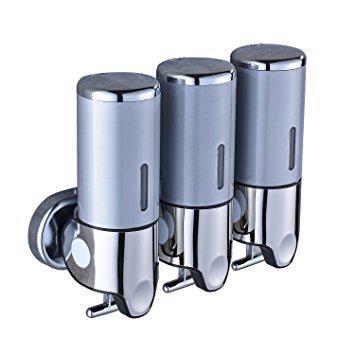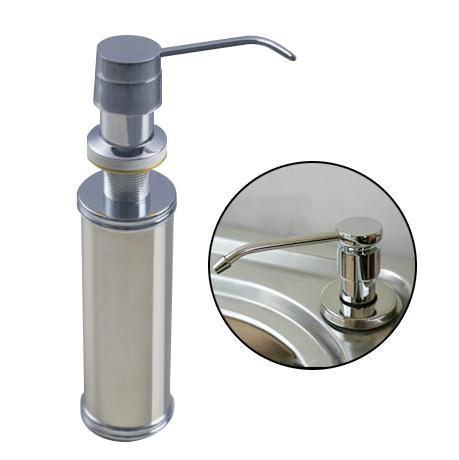The first image is the image on the left, the second image is the image on the right. Considering the images on both sides, is "A dispenser has a spout coming out from the top." valid? Answer yes or no. Yes. The first image is the image on the left, the second image is the image on the right. For the images shown, is this caption "One image shows a cylindrical dispenser with a pump top and nozzle." true? Answer yes or no. Yes. 